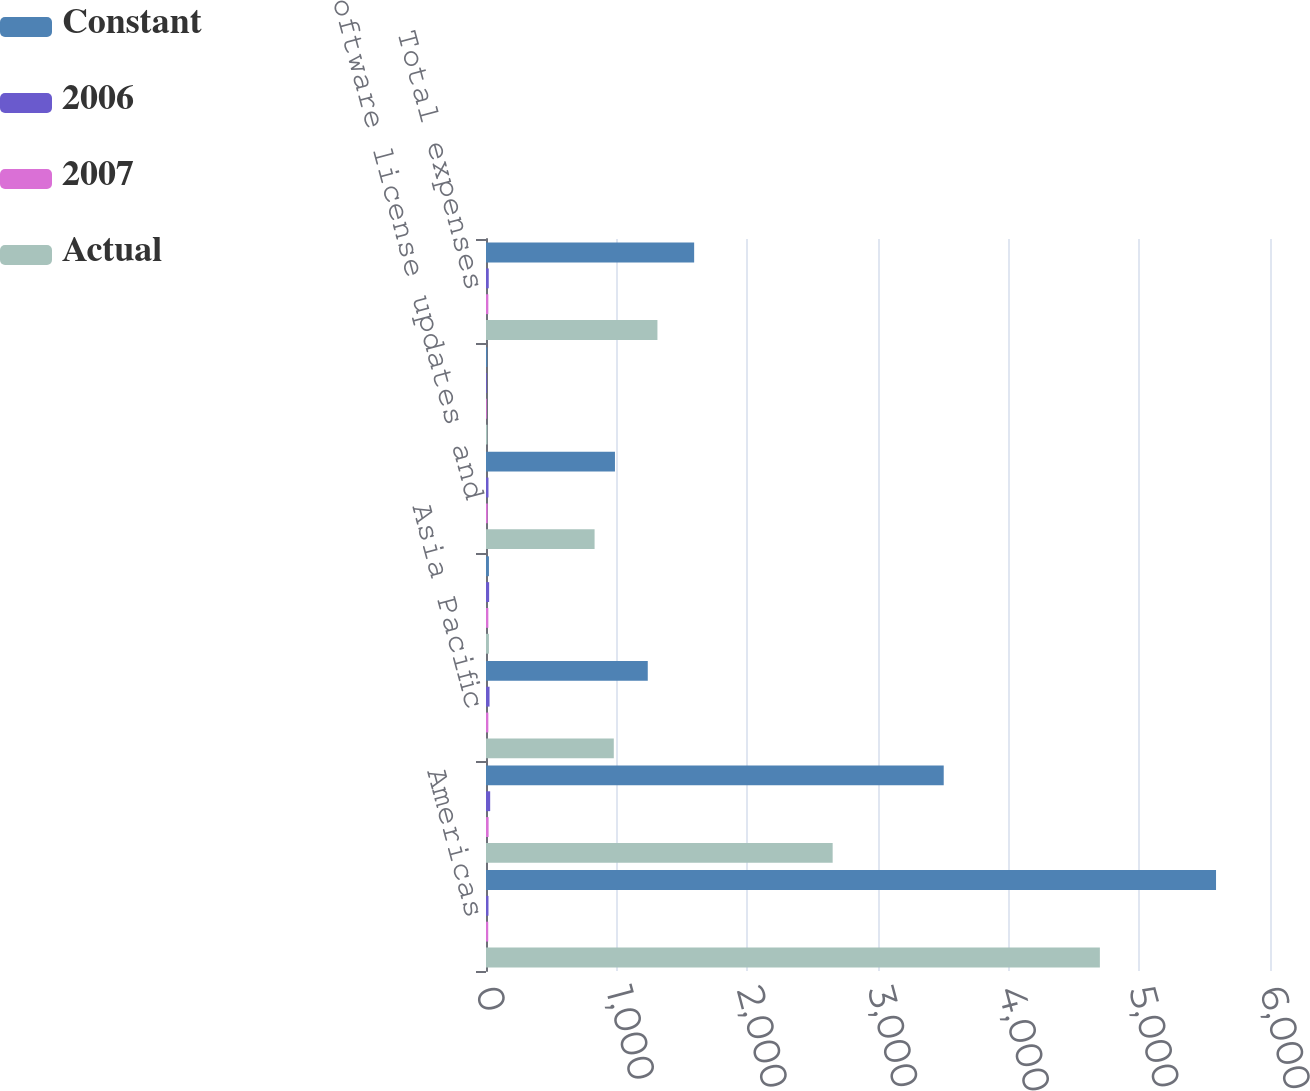Convert chart. <chart><loc_0><loc_0><loc_500><loc_500><stacked_bar_chart><ecel><fcel>Americas<fcel>EMEA<fcel>Asia Pacific<fcel>Total revenues<fcel>Software license updates and<fcel>Stock-based compensation<fcel>Total expenses<nl><fcel>Constant<fcel>5587<fcel>3503<fcel>1238<fcel>22.5<fcel>987<fcel>10<fcel>1593<nl><fcel>2006<fcel>19<fcel>32<fcel>27<fcel>24<fcel>19<fcel>6<fcel>21<nl><fcel>2007<fcel>17<fcel>20<fcel>18<fcel>18<fcel>13<fcel>6<fcel>18<nl><fcel>Actual<fcel>4698<fcel>2653<fcel>978<fcel>22.5<fcel>831<fcel>11<fcel>1312<nl></chart> 